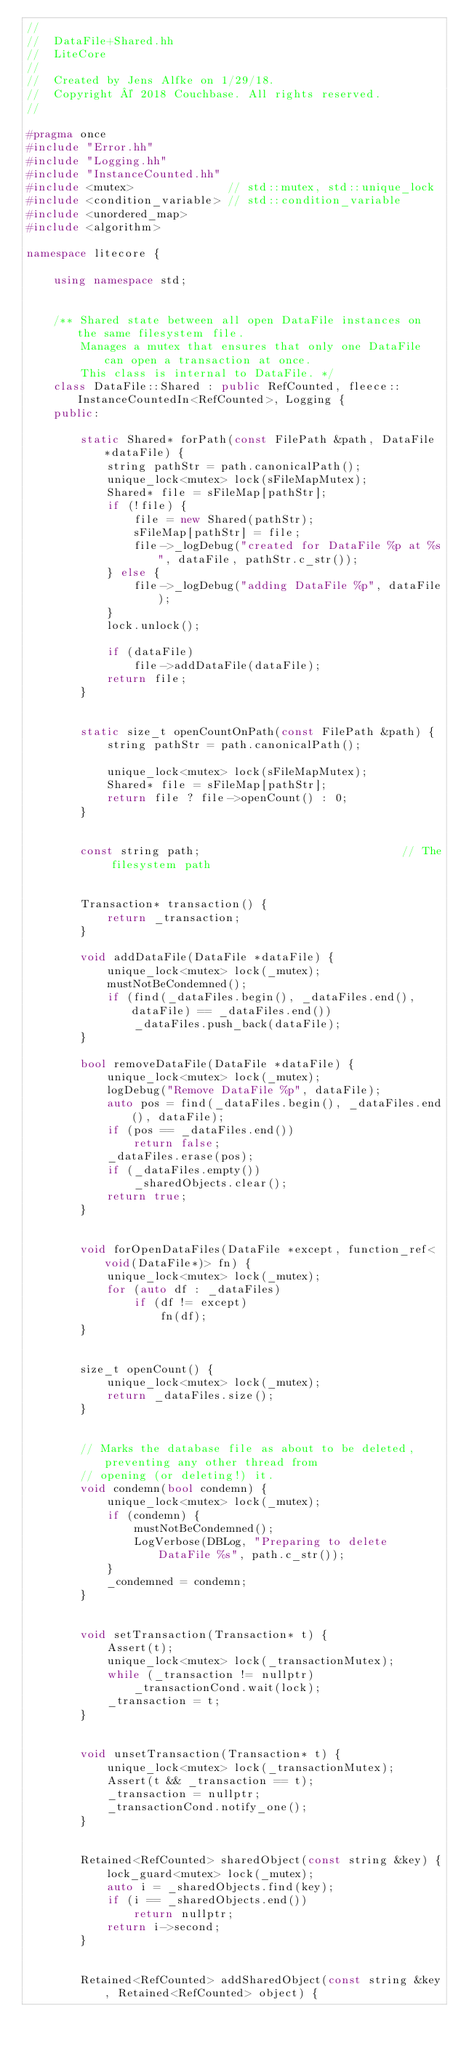<code> <loc_0><loc_0><loc_500><loc_500><_C++_>//
//  DataFile+Shared.hh
//  LiteCore
//
//  Created by Jens Alfke on 1/29/18.
//  Copyright © 2018 Couchbase. All rights reserved.
//

#pragma once
#include "Error.hh"
#include "Logging.hh"
#include "InstanceCounted.hh"
#include <mutex>              // std::mutex, std::unique_lock
#include <condition_variable> // std::condition_variable
#include <unordered_map>
#include <algorithm>

namespace litecore {

    using namespace std;


    /** Shared state between all open DataFile instances on the same filesystem file.
        Manages a mutex that ensures that only one DataFile can open a transaction at once.
        This class is internal to DataFile. */
    class DataFile::Shared : public RefCounted, fleece::InstanceCountedIn<RefCounted>, Logging {
    public:

        static Shared* forPath(const FilePath &path, DataFile *dataFile) {
            string pathStr = path.canonicalPath();
            unique_lock<mutex> lock(sFileMapMutex);
            Shared* file = sFileMap[pathStr];
            if (!file) {
                file = new Shared(pathStr);
                sFileMap[pathStr] = file;
                file->_logDebug("created for DataFile %p at %s", dataFile, pathStr.c_str());
            } else {
                file->_logDebug("adding DataFile %p", dataFile);
            }
            lock.unlock();

            if (dataFile)
                file->addDataFile(dataFile);
            return file;
        }


        static size_t openCountOnPath(const FilePath &path) {
            string pathStr = path.canonicalPath();

            unique_lock<mutex> lock(sFileMapMutex);
            Shared* file = sFileMap[pathStr];
            return file ? file->openCount() : 0;
        }


        const string path;                              // The filesystem path


        Transaction* transaction() {
            return _transaction;
        }

        void addDataFile(DataFile *dataFile) {
            unique_lock<mutex> lock(_mutex);
            mustNotBeCondemned();
            if (find(_dataFiles.begin(), _dataFiles.end(), dataFile) == _dataFiles.end())
                _dataFiles.push_back(dataFile);
        }

        bool removeDataFile(DataFile *dataFile) {
            unique_lock<mutex> lock(_mutex);
            logDebug("Remove DataFile %p", dataFile);
            auto pos = find(_dataFiles.begin(), _dataFiles.end(), dataFile);
            if (pos == _dataFiles.end())
                return false;
            _dataFiles.erase(pos);
            if (_dataFiles.empty())
                _sharedObjects.clear();
            return true;
        }


        void forOpenDataFiles(DataFile *except, function_ref<void(DataFile*)> fn) {
            unique_lock<mutex> lock(_mutex);
            for (auto df : _dataFiles)
                if (df != except)
                    fn(df);
        }


        size_t openCount() {
            unique_lock<mutex> lock(_mutex);
            return _dataFiles.size();
        }


        // Marks the database file as about to be deleted, preventing any other thread from
        // opening (or deleting!) it.
        void condemn(bool condemn) {
            unique_lock<mutex> lock(_mutex);
            if (condemn) {
                mustNotBeCondemned();
                LogVerbose(DBLog, "Preparing to delete DataFile %s", path.c_str());
            }
            _condemned = condemn;
        }


        void setTransaction(Transaction* t) {
            Assert(t);
            unique_lock<mutex> lock(_transactionMutex);
            while (_transaction != nullptr)
                _transactionCond.wait(lock);
            _transaction = t;
        }


        void unsetTransaction(Transaction* t) {
            unique_lock<mutex> lock(_transactionMutex);
            Assert(t && _transaction == t);
            _transaction = nullptr;
            _transactionCond.notify_one();
        }


        Retained<RefCounted> sharedObject(const string &key) {
            lock_guard<mutex> lock(_mutex);
            auto i = _sharedObjects.find(key);
            if (i == _sharedObjects.end())
                return nullptr;
            return i->second;
        }


        Retained<RefCounted> addSharedObject(const string &key, Retained<RefCounted> object) {</code> 